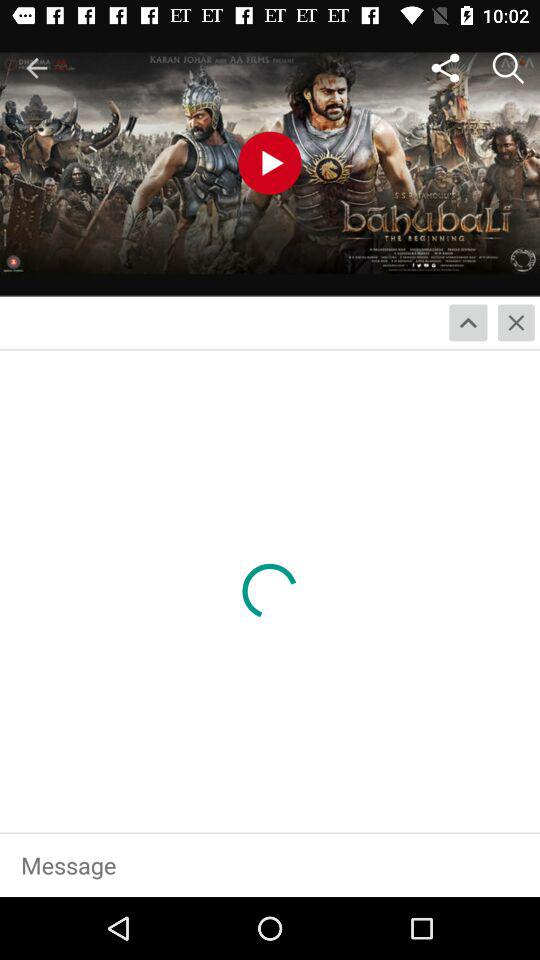What is the name of the movie? The name of the movie is "bahubaLi THE BEGINNING". 